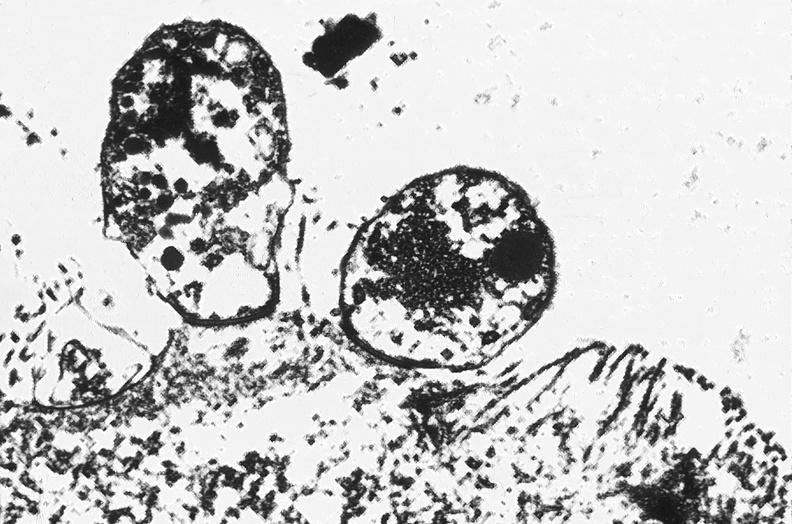s vasculature present?
Answer the question using a single word or phrase. No 